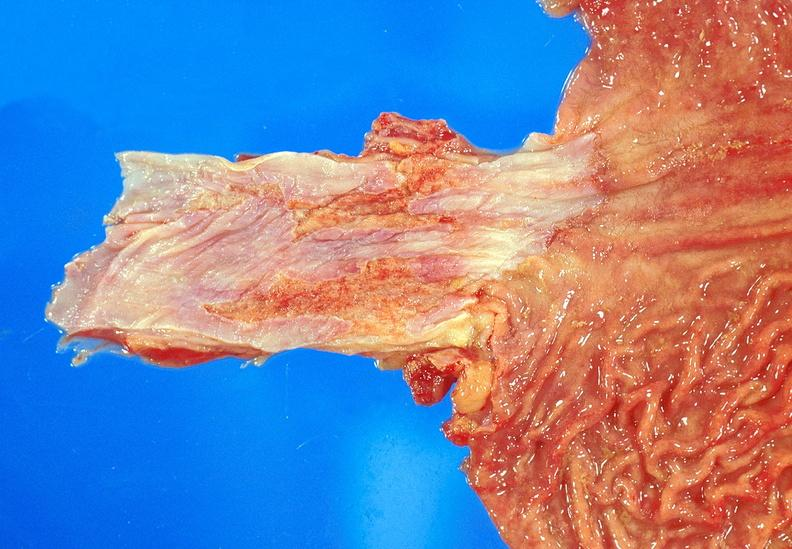s marked present?
Answer the question using a single word or phrase. No 